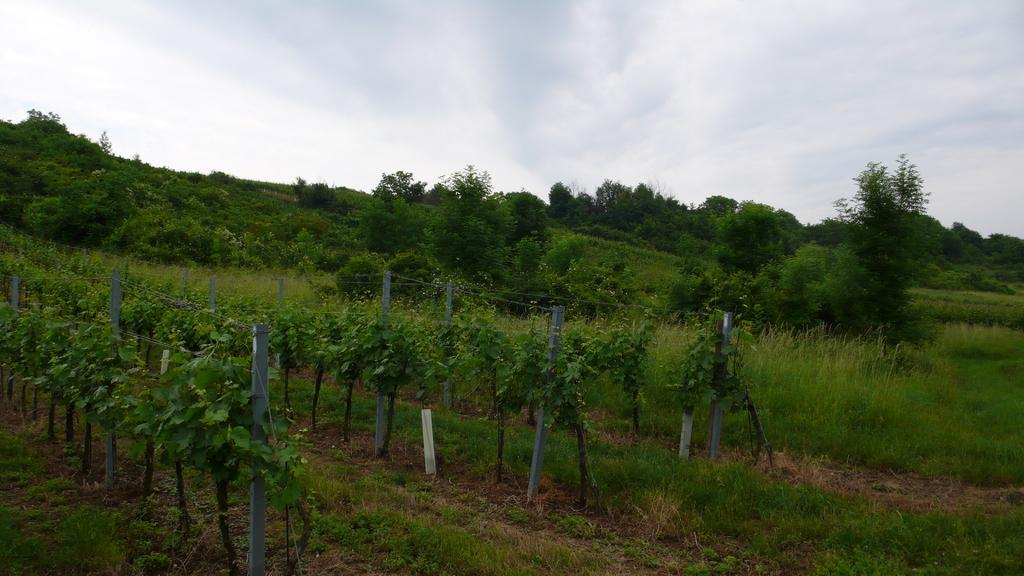What type of vegetation can be seen in the image? There are plants, grass, and trees in the image. What structures are present in the image? There are poles in the image. What can be seen in the background of the image? The sky is visible in the background of the image. What type of payment is being made in the image? There is no payment being made in the image; it features plants, grass, poles, trees, and the sky. What event is taking place in the image? There is no specific event taking place in the image; it simply shows a natural scene with plants, grass, poles, trees, and the sky. 